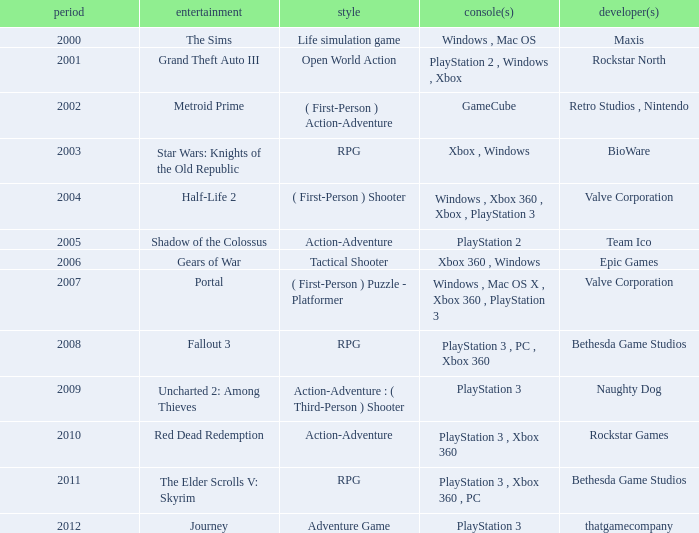What's the platform that has Rockstar Games as the developer? PlayStation 3 , Xbox 360. Parse the full table. {'header': ['period', 'entertainment', 'style', 'console(s)', 'developer(s)'], 'rows': [['2000', 'The Sims', 'Life simulation game', 'Windows , Mac OS', 'Maxis'], ['2001', 'Grand Theft Auto III', 'Open World Action', 'PlayStation 2 , Windows , Xbox', 'Rockstar North'], ['2002', 'Metroid Prime', '( First-Person ) Action-Adventure', 'GameCube', 'Retro Studios , Nintendo'], ['2003', 'Star Wars: Knights of the Old Republic', 'RPG', 'Xbox , Windows', 'BioWare'], ['2004', 'Half-Life 2', '( First-Person ) Shooter', 'Windows , Xbox 360 , Xbox , PlayStation 3', 'Valve Corporation'], ['2005', 'Shadow of the Colossus', 'Action-Adventure', 'PlayStation 2', 'Team Ico'], ['2006', 'Gears of War', 'Tactical Shooter', 'Xbox 360 , Windows', 'Epic Games'], ['2007', 'Portal', '( First-Person ) Puzzle - Platformer', 'Windows , Mac OS X , Xbox 360 , PlayStation 3', 'Valve Corporation'], ['2008', 'Fallout 3', 'RPG', 'PlayStation 3 , PC , Xbox 360', 'Bethesda Game Studios'], ['2009', 'Uncharted 2: Among Thieves', 'Action-Adventure : ( Third-Person ) Shooter', 'PlayStation 3', 'Naughty Dog'], ['2010', 'Red Dead Redemption', 'Action-Adventure', 'PlayStation 3 , Xbox 360', 'Rockstar Games'], ['2011', 'The Elder Scrolls V: Skyrim', 'RPG', 'PlayStation 3 , Xbox 360 , PC', 'Bethesda Game Studios'], ['2012', 'Journey', 'Adventure Game', 'PlayStation 3', 'thatgamecompany']]} 